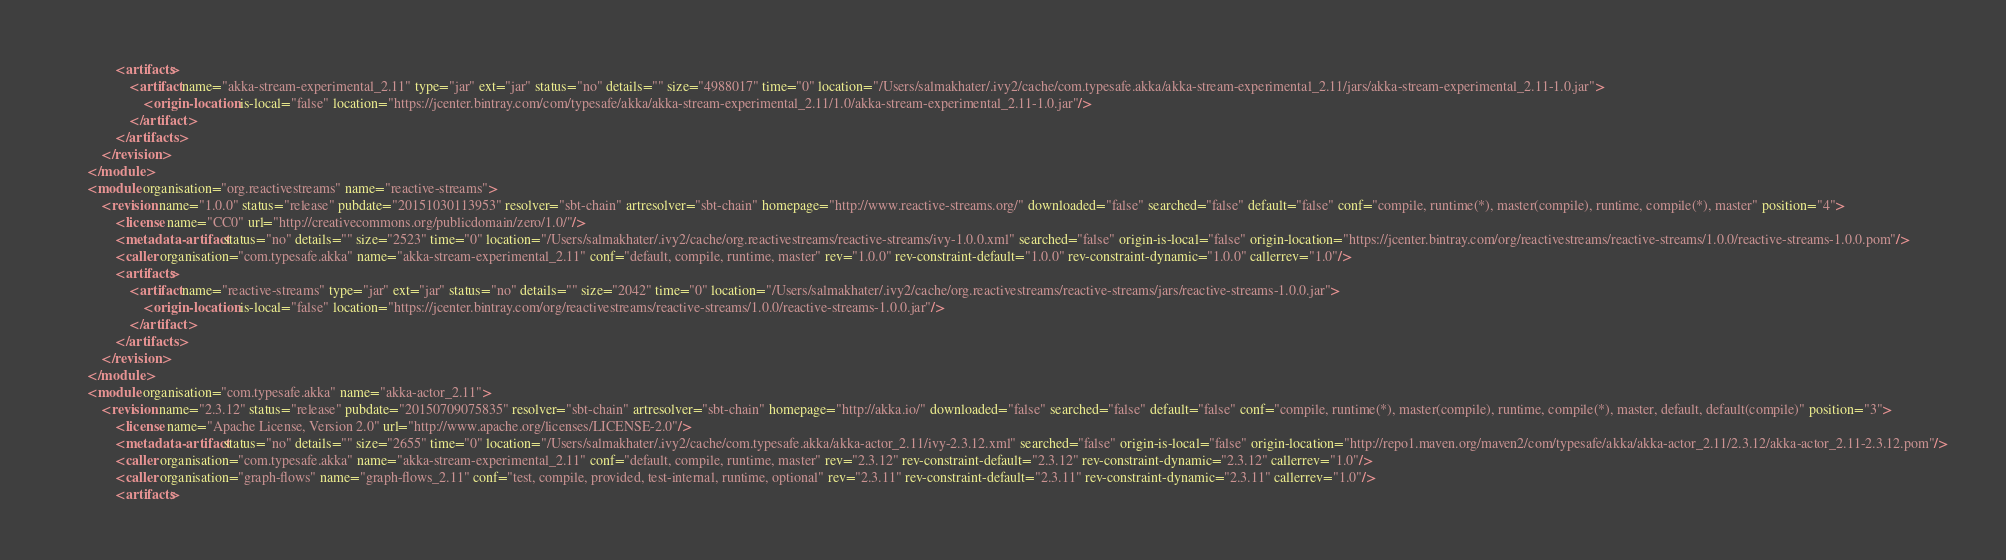<code> <loc_0><loc_0><loc_500><loc_500><_XML_>				<artifacts>
					<artifact name="akka-stream-experimental_2.11" type="jar" ext="jar" status="no" details="" size="4988017" time="0" location="/Users/salmakhater/.ivy2/cache/com.typesafe.akka/akka-stream-experimental_2.11/jars/akka-stream-experimental_2.11-1.0.jar">
						<origin-location is-local="false" location="https://jcenter.bintray.com/com/typesafe/akka/akka-stream-experimental_2.11/1.0/akka-stream-experimental_2.11-1.0.jar"/>
					</artifact>
				</artifacts>
			</revision>
		</module>
		<module organisation="org.reactivestreams" name="reactive-streams">
			<revision name="1.0.0" status="release" pubdate="20151030113953" resolver="sbt-chain" artresolver="sbt-chain" homepage="http://www.reactive-streams.org/" downloaded="false" searched="false" default="false" conf="compile, runtime(*), master(compile), runtime, compile(*), master" position="4">
				<license name="CC0" url="http://creativecommons.org/publicdomain/zero/1.0/"/>
				<metadata-artifact status="no" details="" size="2523" time="0" location="/Users/salmakhater/.ivy2/cache/org.reactivestreams/reactive-streams/ivy-1.0.0.xml" searched="false" origin-is-local="false" origin-location="https://jcenter.bintray.com/org/reactivestreams/reactive-streams/1.0.0/reactive-streams-1.0.0.pom"/>
				<caller organisation="com.typesafe.akka" name="akka-stream-experimental_2.11" conf="default, compile, runtime, master" rev="1.0.0" rev-constraint-default="1.0.0" rev-constraint-dynamic="1.0.0" callerrev="1.0"/>
				<artifacts>
					<artifact name="reactive-streams" type="jar" ext="jar" status="no" details="" size="2042" time="0" location="/Users/salmakhater/.ivy2/cache/org.reactivestreams/reactive-streams/jars/reactive-streams-1.0.0.jar">
						<origin-location is-local="false" location="https://jcenter.bintray.com/org/reactivestreams/reactive-streams/1.0.0/reactive-streams-1.0.0.jar"/>
					</artifact>
				</artifacts>
			</revision>
		</module>
		<module organisation="com.typesafe.akka" name="akka-actor_2.11">
			<revision name="2.3.12" status="release" pubdate="20150709075835" resolver="sbt-chain" artresolver="sbt-chain" homepage="http://akka.io/" downloaded="false" searched="false" default="false" conf="compile, runtime(*), master(compile), runtime, compile(*), master, default, default(compile)" position="3">
				<license name="Apache License, Version 2.0" url="http://www.apache.org/licenses/LICENSE-2.0"/>
				<metadata-artifact status="no" details="" size="2655" time="0" location="/Users/salmakhater/.ivy2/cache/com.typesafe.akka/akka-actor_2.11/ivy-2.3.12.xml" searched="false" origin-is-local="false" origin-location="http://repo1.maven.org/maven2/com/typesafe/akka/akka-actor_2.11/2.3.12/akka-actor_2.11-2.3.12.pom"/>
				<caller organisation="com.typesafe.akka" name="akka-stream-experimental_2.11" conf="default, compile, runtime, master" rev="2.3.12" rev-constraint-default="2.3.12" rev-constraint-dynamic="2.3.12" callerrev="1.0"/>
				<caller organisation="graph-flows" name="graph-flows_2.11" conf="test, compile, provided, test-internal, runtime, optional" rev="2.3.11" rev-constraint-default="2.3.11" rev-constraint-dynamic="2.3.11" callerrev="1.0"/>
				<artifacts></code> 